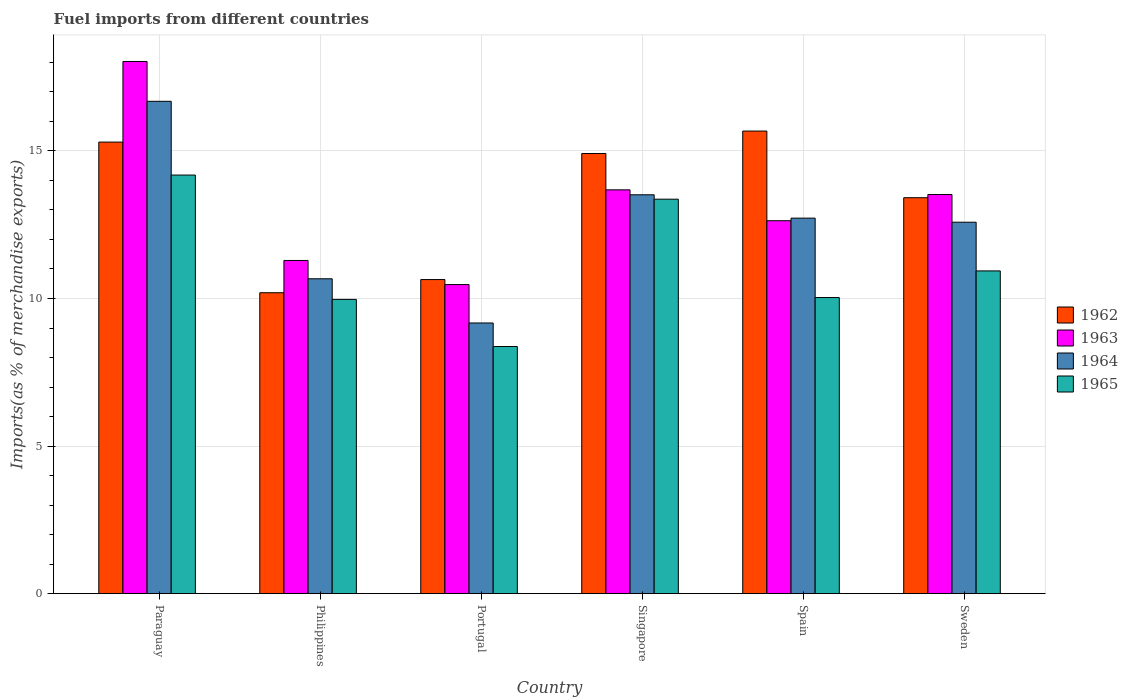Are the number of bars per tick equal to the number of legend labels?
Keep it short and to the point. Yes. Are the number of bars on each tick of the X-axis equal?
Your answer should be compact. Yes. What is the label of the 4th group of bars from the left?
Provide a succinct answer. Singapore. In how many cases, is the number of bars for a given country not equal to the number of legend labels?
Give a very brief answer. 0. What is the percentage of imports to different countries in 1965 in Sweden?
Offer a very short reply. 10.93. Across all countries, what is the maximum percentage of imports to different countries in 1965?
Your response must be concise. 14.18. Across all countries, what is the minimum percentage of imports to different countries in 1964?
Your answer should be very brief. 9.17. In which country was the percentage of imports to different countries in 1963 maximum?
Ensure brevity in your answer.  Paraguay. What is the total percentage of imports to different countries in 1964 in the graph?
Give a very brief answer. 75.34. What is the difference between the percentage of imports to different countries in 1962 in Portugal and that in Singapore?
Give a very brief answer. -4.27. What is the difference between the percentage of imports to different countries in 1962 in Sweden and the percentage of imports to different countries in 1964 in Spain?
Provide a short and direct response. 0.69. What is the average percentage of imports to different countries in 1962 per country?
Your answer should be compact. 13.36. What is the difference between the percentage of imports to different countries of/in 1964 and percentage of imports to different countries of/in 1962 in Philippines?
Keep it short and to the point. 0.47. What is the ratio of the percentage of imports to different countries in 1964 in Philippines to that in Singapore?
Make the answer very short. 0.79. Is the percentage of imports to different countries in 1965 in Portugal less than that in Singapore?
Provide a succinct answer. Yes. Is the difference between the percentage of imports to different countries in 1964 in Philippines and Portugal greater than the difference between the percentage of imports to different countries in 1962 in Philippines and Portugal?
Provide a short and direct response. Yes. What is the difference between the highest and the second highest percentage of imports to different countries in 1962?
Ensure brevity in your answer.  0.39. What is the difference between the highest and the lowest percentage of imports to different countries in 1965?
Keep it short and to the point. 5.81. In how many countries, is the percentage of imports to different countries in 1964 greater than the average percentage of imports to different countries in 1964 taken over all countries?
Keep it short and to the point. 4. Is it the case that in every country, the sum of the percentage of imports to different countries in 1964 and percentage of imports to different countries in 1965 is greater than the sum of percentage of imports to different countries in 1962 and percentage of imports to different countries in 1963?
Give a very brief answer. No. What does the 1st bar from the left in Paraguay represents?
Keep it short and to the point. 1962. How many bars are there?
Provide a succinct answer. 24. How many countries are there in the graph?
Give a very brief answer. 6. Where does the legend appear in the graph?
Provide a succinct answer. Center right. What is the title of the graph?
Provide a short and direct response. Fuel imports from different countries. What is the label or title of the X-axis?
Ensure brevity in your answer.  Country. What is the label or title of the Y-axis?
Your response must be concise. Imports(as % of merchandise exports). What is the Imports(as % of merchandise exports) in 1962 in Paraguay?
Keep it short and to the point. 15.3. What is the Imports(as % of merchandise exports) of 1963 in Paraguay?
Make the answer very short. 18.03. What is the Imports(as % of merchandise exports) in 1964 in Paraguay?
Give a very brief answer. 16.68. What is the Imports(as % of merchandise exports) of 1965 in Paraguay?
Your answer should be compact. 14.18. What is the Imports(as % of merchandise exports) of 1962 in Philippines?
Your response must be concise. 10.2. What is the Imports(as % of merchandise exports) in 1963 in Philippines?
Your response must be concise. 11.29. What is the Imports(as % of merchandise exports) of 1964 in Philippines?
Your answer should be very brief. 10.67. What is the Imports(as % of merchandise exports) in 1965 in Philippines?
Your answer should be compact. 9.97. What is the Imports(as % of merchandise exports) in 1962 in Portugal?
Make the answer very short. 10.64. What is the Imports(as % of merchandise exports) in 1963 in Portugal?
Provide a succinct answer. 10.47. What is the Imports(as % of merchandise exports) of 1964 in Portugal?
Give a very brief answer. 9.17. What is the Imports(as % of merchandise exports) of 1965 in Portugal?
Offer a very short reply. 8.37. What is the Imports(as % of merchandise exports) in 1962 in Singapore?
Your answer should be very brief. 14.91. What is the Imports(as % of merchandise exports) of 1963 in Singapore?
Offer a very short reply. 13.68. What is the Imports(as % of merchandise exports) of 1964 in Singapore?
Provide a short and direct response. 13.51. What is the Imports(as % of merchandise exports) of 1965 in Singapore?
Make the answer very short. 13.37. What is the Imports(as % of merchandise exports) of 1962 in Spain?
Give a very brief answer. 15.67. What is the Imports(as % of merchandise exports) of 1963 in Spain?
Make the answer very short. 12.64. What is the Imports(as % of merchandise exports) in 1964 in Spain?
Make the answer very short. 12.72. What is the Imports(as % of merchandise exports) of 1965 in Spain?
Provide a short and direct response. 10.03. What is the Imports(as % of merchandise exports) in 1962 in Sweden?
Your response must be concise. 13.42. What is the Imports(as % of merchandise exports) in 1963 in Sweden?
Ensure brevity in your answer.  13.52. What is the Imports(as % of merchandise exports) of 1964 in Sweden?
Your answer should be very brief. 12.58. What is the Imports(as % of merchandise exports) in 1965 in Sweden?
Keep it short and to the point. 10.93. Across all countries, what is the maximum Imports(as % of merchandise exports) of 1962?
Give a very brief answer. 15.67. Across all countries, what is the maximum Imports(as % of merchandise exports) in 1963?
Your response must be concise. 18.03. Across all countries, what is the maximum Imports(as % of merchandise exports) of 1964?
Make the answer very short. 16.68. Across all countries, what is the maximum Imports(as % of merchandise exports) in 1965?
Offer a terse response. 14.18. Across all countries, what is the minimum Imports(as % of merchandise exports) in 1962?
Provide a succinct answer. 10.2. Across all countries, what is the minimum Imports(as % of merchandise exports) of 1963?
Offer a very short reply. 10.47. Across all countries, what is the minimum Imports(as % of merchandise exports) of 1964?
Your response must be concise. 9.17. Across all countries, what is the minimum Imports(as % of merchandise exports) of 1965?
Keep it short and to the point. 8.37. What is the total Imports(as % of merchandise exports) in 1962 in the graph?
Offer a terse response. 80.14. What is the total Imports(as % of merchandise exports) of 1963 in the graph?
Your answer should be compact. 79.63. What is the total Imports(as % of merchandise exports) of 1964 in the graph?
Offer a terse response. 75.34. What is the total Imports(as % of merchandise exports) of 1965 in the graph?
Offer a terse response. 66.86. What is the difference between the Imports(as % of merchandise exports) in 1962 in Paraguay and that in Philippines?
Make the answer very short. 5.1. What is the difference between the Imports(as % of merchandise exports) of 1963 in Paraguay and that in Philippines?
Provide a succinct answer. 6.74. What is the difference between the Imports(as % of merchandise exports) in 1964 in Paraguay and that in Philippines?
Ensure brevity in your answer.  6.01. What is the difference between the Imports(as % of merchandise exports) in 1965 in Paraguay and that in Philippines?
Offer a terse response. 4.21. What is the difference between the Imports(as % of merchandise exports) of 1962 in Paraguay and that in Portugal?
Offer a very short reply. 4.66. What is the difference between the Imports(as % of merchandise exports) of 1963 in Paraguay and that in Portugal?
Your answer should be very brief. 7.56. What is the difference between the Imports(as % of merchandise exports) in 1964 in Paraguay and that in Portugal?
Provide a succinct answer. 7.51. What is the difference between the Imports(as % of merchandise exports) in 1965 in Paraguay and that in Portugal?
Make the answer very short. 5.81. What is the difference between the Imports(as % of merchandise exports) in 1962 in Paraguay and that in Singapore?
Offer a terse response. 0.39. What is the difference between the Imports(as % of merchandise exports) of 1963 in Paraguay and that in Singapore?
Ensure brevity in your answer.  4.35. What is the difference between the Imports(as % of merchandise exports) of 1964 in Paraguay and that in Singapore?
Give a very brief answer. 3.17. What is the difference between the Imports(as % of merchandise exports) in 1965 in Paraguay and that in Singapore?
Make the answer very short. 0.82. What is the difference between the Imports(as % of merchandise exports) of 1962 in Paraguay and that in Spain?
Your answer should be compact. -0.37. What is the difference between the Imports(as % of merchandise exports) of 1963 in Paraguay and that in Spain?
Offer a very short reply. 5.4. What is the difference between the Imports(as % of merchandise exports) in 1964 in Paraguay and that in Spain?
Your response must be concise. 3.96. What is the difference between the Imports(as % of merchandise exports) in 1965 in Paraguay and that in Spain?
Your answer should be very brief. 4.15. What is the difference between the Imports(as % of merchandise exports) of 1962 in Paraguay and that in Sweden?
Provide a succinct answer. 1.88. What is the difference between the Imports(as % of merchandise exports) in 1963 in Paraguay and that in Sweden?
Your response must be concise. 4.51. What is the difference between the Imports(as % of merchandise exports) in 1964 in Paraguay and that in Sweden?
Give a very brief answer. 4.1. What is the difference between the Imports(as % of merchandise exports) in 1965 in Paraguay and that in Sweden?
Offer a very short reply. 3.25. What is the difference between the Imports(as % of merchandise exports) in 1962 in Philippines and that in Portugal?
Offer a terse response. -0.45. What is the difference between the Imports(as % of merchandise exports) in 1963 in Philippines and that in Portugal?
Offer a very short reply. 0.82. What is the difference between the Imports(as % of merchandise exports) in 1964 in Philippines and that in Portugal?
Provide a succinct answer. 1.5. What is the difference between the Imports(as % of merchandise exports) in 1965 in Philippines and that in Portugal?
Your response must be concise. 1.6. What is the difference between the Imports(as % of merchandise exports) in 1962 in Philippines and that in Singapore?
Ensure brevity in your answer.  -4.72. What is the difference between the Imports(as % of merchandise exports) of 1963 in Philippines and that in Singapore?
Make the answer very short. -2.39. What is the difference between the Imports(as % of merchandise exports) in 1964 in Philippines and that in Singapore?
Offer a terse response. -2.85. What is the difference between the Imports(as % of merchandise exports) of 1965 in Philippines and that in Singapore?
Offer a very short reply. -3.4. What is the difference between the Imports(as % of merchandise exports) of 1962 in Philippines and that in Spain?
Keep it short and to the point. -5.48. What is the difference between the Imports(as % of merchandise exports) of 1963 in Philippines and that in Spain?
Your response must be concise. -1.35. What is the difference between the Imports(as % of merchandise exports) of 1964 in Philippines and that in Spain?
Provide a short and direct response. -2.05. What is the difference between the Imports(as % of merchandise exports) of 1965 in Philippines and that in Spain?
Your answer should be compact. -0.06. What is the difference between the Imports(as % of merchandise exports) of 1962 in Philippines and that in Sweden?
Provide a succinct answer. -3.22. What is the difference between the Imports(as % of merchandise exports) of 1963 in Philippines and that in Sweden?
Your answer should be compact. -2.23. What is the difference between the Imports(as % of merchandise exports) of 1964 in Philippines and that in Sweden?
Your response must be concise. -1.92. What is the difference between the Imports(as % of merchandise exports) in 1965 in Philippines and that in Sweden?
Ensure brevity in your answer.  -0.96. What is the difference between the Imports(as % of merchandise exports) in 1962 in Portugal and that in Singapore?
Your response must be concise. -4.27. What is the difference between the Imports(as % of merchandise exports) of 1963 in Portugal and that in Singapore?
Provide a succinct answer. -3.21. What is the difference between the Imports(as % of merchandise exports) of 1964 in Portugal and that in Singapore?
Make the answer very short. -4.34. What is the difference between the Imports(as % of merchandise exports) in 1965 in Portugal and that in Singapore?
Your response must be concise. -4.99. What is the difference between the Imports(as % of merchandise exports) of 1962 in Portugal and that in Spain?
Offer a terse response. -5.03. What is the difference between the Imports(as % of merchandise exports) in 1963 in Portugal and that in Spain?
Your response must be concise. -2.16. What is the difference between the Imports(as % of merchandise exports) in 1964 in Portugal and that in Spain?
Your response must be concise. -3.55. What is the difference between the Imports(as % of merchandise exports) in 1965 in Portugal and that in Spain?
Give a very brief answer. -1.66. What is the difference between the Imports(as % of merchandise exports) of 1962 in Portugal and that in Sweden?
Give a very brief answer. -2.77. What is the difference between the Imports(as % of merchandise exports) of 1963 in Portugal and that in Sweden?
Provide a succinct answer. -3.05. What is the difference between the Imports(as % of merchandise exports) in 1964 in Portugal and that in Sweden?
Offer a terse response. -3.41. What is the difference between the Imports(as % of merchandise exports) of 1965 in Portugal and that in Sweden?
Your answer should be very brief. -2.56. What is the difference between the Imports(as % of merchandise exports) of 1962 in Singapore and that in Spain?
Ensure brevity in your answer.  -0.76. What is the difference between the Imports(as % of merchandise exports) in 1963 in Singapore and that in Spain?
Ensure brevity in your answer.  1.05. What is the difference between the Imports(as % of merchandise exports) in 1964 in Singapore and that in Spain?
Provide a short and direct response. 0.79. What is the difference between the Imports(as % of merchandise exports) in 1965 in Singapore and that in Spain?
Make the answer very short. 3.33. What is the difference between the Imports(as % of merchandise exports) of 1962 in Singapore and that in Sweden?
Ensure brevity in your answer.  1.5. What is the difference between the Imports(as % of merchandise exports) of 1963 in Singapore and that in Sweden?
Your response must be concise. 0.16. What is the difference between the Imports(as % of merchandise exports) of 1964 in Singapore and that in Sweden?
Ensure brevity in your answer.  0.93. What is the difference between the Imports(as % of merchandise exports) of 1965 in Singapore and that in Sweden?
Keep it short and to the point. 2.43. What is the difference between the Imports(as % of merchandise exports) of 1962 in Spain and that in Sweden?
Your answer should be compact. 2.26. What is the difference between the Imports(as % of merchandise exports) in 1963 in Spain and that in Sweden?
Ensure brevity in your answer.  -0.89. What is the difference between the Imports(as % of merchandise exports) in 1964 in Spain and that in Sweden?
Offer a very short reply. 0.14. What is the difference between the Imports(as % of merchandise exports) of 1965 in Spain and that in Sweden?
Provide a short and direct response. -0.9. What is the difference between the Imports(as % of merchandise exports) in 1962 in Paraguay and the Imports(as % of merchandise exports) in 1963 in Philippines?
Keep it short and to the point. 4.01. What is the difference between the Imports(as % of merchandise exports) in 1962 in Paraguay and the Imports(as % of merchandise exports) in 1964 in Philippines?
Your answer should be compact. 4.63. What is the difference between the Imports(as % of merchandise exports) of 1962 in Paraguay and the Imports(as % of merchandise exports) of 1965 in Philippines?
Your answer should be very brief. 5.33. What is the difference between the Imports(as % of merchandise exports) of 1963 in Paraguay and the Imports(as % of merchandise exports) of 1964 in Philippines?
Your answer should be very brief. 7.36. What is the difference between the Imports(as % of merchandise exports) in 1963 in Paraguay and the Imports(as % of merchandise exports) in 1965 in Philippines?
Provide a short and direct response. 8.06. What is the difference between the Imports(as % of merchandise exports) of 1964 in Paraguay and the Imports(as % of merchandise exports) of 1965 in Philippines?
Provide a succinct answer. 6.71. What is the difference between the Imports(as % of merchandise exports) in 1962 in Paraguay and the Imports(as % of merchandise exports) in 1963 in Portugal?
Keep it short and to the point. 4.83. What is the difference between the Imports(as % of merchandise exports) in 1962 in Paraguay and the Imports(as % of merchandise exports) in 1964 in Portugal?
Keep it short and to the point. 6.13. What is the difference between the Imports(as % of merchandise exports) of 1962 in Paraguay and the Imports(as % of merchandise exports) of 1965 in Portugal?
Offer a terse response. 6.93. What is the difference between the Imports(as % of merchandise exports) in 1963 in Paraguay and the Imports(as % of merchandise exports) in 1964 in Portugal?
Make the answer very short. 8.86. What is the difference between the Imports(as % of merchandise exports) in 1963 in Paraguay and the Imports(as % of merchandise exports) in 1965 in Portugal?
Keep it short and to the point. 9.66. What is the difference between the Imports(as % of merchandise exports) in 1964 in Paraguay and the Imports(as % of merchandise exports) in 1965 in Portugal?
Provide a succinct answer. 8.31. What is the difference between the Imports(as % of merchandise exports) in 1962 in Paraguay and the Imports(as % of merchandise exports) in 1963 in Singapore?
Provide a succinct answer. 1.62. What is the difference between the Imports(as % of merchandise exports) of 1962 in Paraguay and the Imports(as % of merchandise exports) of 1964 in Singapore?
Ensure brevity in your answer.  1.79. What is the difference between the Imports(as % of merchandise exports) of 1962 in Paraguay and the Imports(as % of merchandise exports) of 1965 in Singapore?
Offer a terse response. 1.93. What is the difference between the Imports(as % of merchandise exports) of 1963 in Paraguay and the Imports(as % of merchandise exports) of 1964 in Singapore?
Give a very brief answer. 4.52. What is the difference between the Imports(as % of merchandise exports) in 1963 in Paraguay and the Imports(as % of merchandise exports) in 1965 in Singapore?
Keep it short and to the point. 4.67. What is the difference between the Imports(as % of merchandise exports) of 1964 in Paraguay and the Imports(as % of merchandise exports) of 1965 in Singapore?
Provide a short and direct response. 3.32. What is the difference between the Imports(as % of merchandise exports) of 1962 in Paraguay and the Imports(as % of merchandise exports) of 1963 in Spain?
Your answer should be compact. 2.66. What is the difference between the Imports(as % of merchandise exports) of 1962 in Paraguay and the Imports(as % of merchandise exports) of 1964 in Spain?
Your answer should be compact. 2.58. What is the difference between the Imports(as % of merchandise exports) in 1962 in Paraguay and the Imports(as % of merchandise exports) in 1965 in Spain?
Provide a short and direct response. 5.27. What is the difference between the Imports(as % of merchandise exports) in 1963 in Paraguay and the Imports(as % of merchandise exports) in 1964 in Spain?
Ensure brevity in your answer.  5.31. What is the difference between the Imports(as % of merchandise exports) of 1963 in Paraguay and the Imports(as % of merchandise exports) of 1965 in Spain?
Your answer should be compact. 8. What is the difference between the Imports(as % of merchandise exports) in 1964 in Paraguay and the Imports(as % of merchandise exports) in 1965 in Spain?
Provide a succinct answer. 6.65. What is the difference between the Imports(as % of merchandise exports) in 1962 in Paraguay and the Imports(as % of merchandise exports) in 1963 in Sweden?
Provide a succinct answer. 1.78. What is the difference between the Imports(as % of merchandise exports) of 1962 in Paraguay and the Imports(as % of merchandise exports) of 1964 in Sweden?
Your answer should be compact. 2.71. What is the difference between the Imports(as % of merchandise exports) of 1962 in Paraguay and the Imports(as % of merchandise exports) of 1965 in Sweden?
Provide a succinct answer. 4.36. What is the difference between the Imports(as % of merchandise exports) of 1963 in Paraguay and the Imports(as % of merchandise exports) of 1964 in Sweden?
Your answer should be very brief. 5.45. What is the difference between the Imports(as % of merchandise exports) in 1963 in Paraguay and the Imports(as % of merchandise exports) in 1965 in Sweden?
Offer a terse response. 7.1. What is the difference between the Imports(as % of merchandise exports) of 1964 in Paraguay and the Imports(as % of merchandise exports) of 1965 in Sweden?
Your answer should be compact. 5.75. What is the difference between the Imports(as % of merchandise exports) of 1962 in Philippines and the Imports(as % of merchandise exports) of 1963 in Portugal?
Keep it short and to the point. -0.28. What is the difference between the Imports(as % of merchandise exports) of 1962 in Philippines and the Imports(as % of merchandise exports) of 1964 in Portugal?
Offer a terse response. 1.03. What is the difference between the Imports(as % of merchandise exports) in 1962 in Philippines and the Imports(as % of merchandise exports) in 1965 in Portugal?
Ensure brevity in your answer.  1.82. What is the difference between the Imports(as % of merchandise exports) in 1963 in Philippines and the Imports(as % of merchandise exports) in 1964 in Portugal?
Your response must be concise. 2.12. What is the difference between the Imports(as % of merchandise exports) in 1963 in Philippines and the Imports(as % of merchandise exports) in 1965 in Portugal?
Provide a short and direct response. 2.92. What is the difference between the Imports(as % of merchandise exports) in 1964 in Philippines and the Imports(as % of merchandise exports) in 1965 in Portugal?
Provide a succinct answer. 2.3. What is the difference between the Imports(as % of merchandise exports) in 1962 in Philippines and the Imports(as % of merchandise exports) in 1963 in Singapore?
Provide a succinct answer. -3.49. What is the difference between the Imports(as % of merchandise exports) of 1962 in Philippines and the Imports(as % of merchandise exports) of 1964 in Singapore?
Make the answer very short. -3.32. What is the difference between the Imports(as % of merchandise exports) in 1962 in Philippines and the Imports(as % of merchandise exports) in 1965 in Singapore?
Keep it short and to the point. -3.17. What is the difference between the Imports(as % of merchandise exports) in 1963 in Philippines and the Imports(as % of merchandise exports) in 1964 in Singapore?
Offer a terse response. -2.23. What is the difference between the Imports(as % of merchandise exports) of 1963 in Philippines and the Imports(as % of merchandise exports) of 1965 in Singapore?
Keep it short and to the point. -2.08. What is the difference between the Imports(as % of merchandise exports) in 1964 in Philippines and the Imports(as % of merchandise exports) in 1965 in Singapore?
Provide a short and direct response. -2.7. What is the difference between the Imports(as % of merchandise exports) in 1962 in Philippines and the Imports(as % of merchandise exports) in 1963 in Spain?
Your response must be concise. -2.44. What is the difference between the Imports(as % of merchandise exports) of 1962 in Philippines and the Imports(as % of merchandise exports) of 1964 in Spain?
Your answer should be very brief. -2.53. What is the difference between the Imports(as % of merchandise exports) in 1962 in Philippines and the Imports(as % of merchandise exports) in 1965 in Spain?
Ensure brevity in your answer.  0.16. What is the difference between the Imports(as % of merchandise exports) of 1963 in Philippines and the Imports(as % of merchandise exports) of 1964 in Spain?
Ensure brevity in your answer.  -1.43. What is the difference between the Imports(as % of merchandise exports) of 1963 in Philippines and the Imports(as % of merchandise exports) of 1965 in Spain?
Give a very brief answer. 1.26. What is the difference between the Imports(as % of merchandise exports) in 1964 in Philippines and the Imports(as % of merchandise exports) in 1965 in Spain?
Offer a very short reply. 0.64. What is the difference between the Imports(as % of merchandise exports) of 1962 in Philippines and the Imports(as % of merchandise exports) of 1963 in Sweden?
Offer a terse response. -3.33. What is the difference between the Imports(as % of merchandise exports) of 1962 in Philippines and the Imports(as % of merchandise exports) of 1964 in Sweden?
Ensure brevity in your answer.  -2.39. What is the difference between the Imports(as % of merchandise exports) in 1962 in Philippines and the Imports(as % of merchandise exports) in 1965 in Sweden?
Your answer should be compact. -0.74. What is the difference between the Imports(as % of merchandise exports) in 1963 in Philippines and the Imports(as % of merchandise exports) in 1964 in Sweden?
Keep it short and to the point. -1.3. What is the difference between the Imports(as % of merchandise exports) in 1963 in Philippines and the Imports(as % of merchandise exports) in 1965 in Sweden?
Provide a succinct answer. 0.35. What is the difference between the Imports(as % of merchandise exports) in 1964 in Philippines and the Imports(as % of merchandise exports) in 1965 in Sweden?
Your answer should be very brief. -0.27. What is the difference between the Imports(as % of merchandise exports) in 1962 in Portugal and the Imports(as % of merchandise exports) in 1963 in Singapore?
Your response must be concise. -3.04. What is the difference between the Imports(as % of merchandise exports) in 1962 in Portugal and the Imports(as % of merchandise exports) in 1964 in Singapore?
Give a very brief answer. -2.87. What is the difference between the Imports(as % of merchandise exports) of 1962 in Portugal and the Imports(as % of merchandise exports) of 1965 in Singapore?
Make the answer very short. -2.72. What is the difference between the Imports(as % of merchandise exports) of 1963 in Portugal and the Imports(as % of merchandise exports) of 1964 in Singapore?
Provide a succinct answer. -3.04. What is the difference between the Imports(as % of merchandise exports) of 1963 in Portugal and the Imports(as % of merchandise exports) of 1965 in Singapore?
Keep it short and to the point. -2.89. What is the difference between the Imports(as % of merchandise exports) of 1964 in Portugal and the Imports(as % of merchandise exports) of 1965 in Singapore?
Your response must be concise. -4.19. What is the difference between the Imports(as % of merchandise exports) of 1962 in Portugal and the Imports(as % of merchandise exports) of 1963 in Spain?
Your answer should be very brief. -1.99. What is the difference between the Imports(as % of merchandise exports) in 1962 in Portugal and the Imports(as % of merchandise exports) in 1964 in Spain?
Offer a terse response. -2.08. What is the difference between the Imports(as % of merchandise exports) in 1962 in Portugal and the Imports(as % of merchandise exports) in 1965 in Spain?
Give a very brief answer. 0.61. What is the difference between the Imports(as % of merchandise exports) in 1963 in Portugal and the Imports(as % of merchandise exports) in 1964 in Spain?
Your response must be concise. -2.25. What is the difference between the Imports(as % of merchandise exports) of 1963 in Portugal and the Imports(as % of merchandise exports) of 1965 in Spain?
Your response must be concise. 0.44. What is the difference between the Imports(as % of merchandise exports) of 1964 in Portugal and the Imports(as % of merchandise exports) of 1965 in Spain?
Provide a succinct answer. -0.86. What is the difference between the Imports(as % of merchandise exports) in 1962 in Portugal and the Imports(as % of merchandise exports) in 1963 in Sweden?
Your response must be concise. -2.88. What is the difference between the Imports(as % of merchandise exports) in 1962 in Portugal and the Imports(as % of merchandise exports) in 1964 in Sweden?
Provide a succinct answer. -1.94. What is the difference between the Imports(as % of merchandise exports) of 1962 in Portugal and the Imports(as % of merchandise exports) of 1965 in Sweden?
Provide a succinct answer. -0.29. What is the difference between the Imports(as % of merchandise exports) of 1963 in Portugal and the Imports(as % of merchandise exports) of 1964 in Sweden?
Offer a terse response. -2.11. What is the difference between the Imports(as % of merchandise exports) in 1963 in Portugal and the Imports(as % of merchandise exports) in 1965 in Sweden?
Your answer should be very brief. -0.46. What is the difference between the Imports(as % of merchandise exports) in 1964 in Portugal and the Imports(as % of merchandise exports) in 1965 in Sweden?
Keep it short and to the point. -1.76. What is the difference between the Imports(as % of merchandise exports) of 1962 in Singapore and the Imports(as % of merchandise exports) of 1963 in Spain?
Offer a very short reply. 2.28. What is the difference between the Imports(as % of merchandise exports) in 1962 in Singapore and the Imports(as % of merchandise exports) in 1964 in Spain?
Provide a short and direct response. 2.19. What is the difference between the Imports(as % of merchandise exports) in 1962 in Singapore and the Imports(as % of merchandise exports) in 1965 in Spain?
Ensure brevity in your answer.  4.88. What is the difference between the Imports(as % of merchandise exports) of 1963 in Singapore and the Imports(as % of merchandise exports) of 1964 in Spain?
Your response must be concise. 0.96. What is the difference between the Imports(as % of merchandise exports) in 1963 in Singapore and the Imports(as % of merchandise exports) in 1965 in Spain?
Give a very brief answer. 3.65. What is the difference between the Imports(as % of merchandise exports) in 1964 in Singapore and the Imports(as % of merchandise exports) in 1965 in Spain?
Your answer should be compact. 3.48. What is the difference between the Imports(as % of merchandise exports) of 1962 in Singapore and the Imports(as % of merchandise exports) of 1963 in Sweden?
Provide a short and direct response. 1.39. What is the difference between the Imports(as % of merchandise exports) in 1962 in Singapore and the Imports(as % of merchandise exports) in 1964 in Sweden?
Your response must be concise. 2.33. What is the difference between the Imports(as % of merchandise exports) of 1962 in Singapore and the Imports(as % of merchandise exports) of 1965 in Sweden?
Offer a terse response. 3.98. What is the difference between the Imports(as % of merchandise exports) of 1963 in Singapore and the Imports(as % of merchandise exports) of 1964 in Sweden?
Offer a very short reply. 1.1. What is the difference between the Imports(as % of merchandise exports) in 1963 in Singapore and the Imports(as % of merchandise exports) in 1965 in Sweden?
Your response must be concise. 2.75. What is the difference between the Imports(as % of merchandise exports) of 1964 in Singapore and the Imports(as % of merchandise exports) of 1965 in Sweden?
Provide a succinct answer. 2.58. What is the difference between the Imports(as % of merchandise exports) of 1962 in Spain and the Imports(as % of merchandise exports) of 1963 in Sweden?
Offer a terse response. 2.15. What is the difference between the Imports(as % of merchandise exports) of 1962 in Spain and the Imports(as % of merchandise exports) of 1964 in Sweden?
Provide a succinct answer. 3.09. What is the difference between the Imports(as % of merchandise exports) in 1962 in Spain and the Imports(as % of merchandise exports) in 1965 in Sweden?
Your answer should be very brief. 4.74. What is the difference between the Imports(as % of merchandise exports) of 1963 in Spain and the Imports(as % of merchandise exports) of 1964 in Sweden?
Your answer should be compact. 0.05. What is the difference between the Imports(as % of merchandise exports) of 1963 in Spain and the Imports(as % of merchandise exports) of 1965 in Sweden?
Offer a terse response. 1.7. What is the difference between the Imports(as % of merchandise exports) in 1964 in Spain and the Imports(as % of merchandise exports) in 1965 in Sweden?
Keep it short and to the point. 1.79. What is the average Imports(as % of merchandise exports) of 1962 per country?
Keep it short and to the point. 13.36. What is the average Imports(as % of merchandise exports) of 1963 per country?
Offer a terse response. 13.27. What is the average Imports(as % of merchandise exports) in 1964 per country?
Provide a short and direct response. 12.56. What is the average Imports(as % of merchandise exports) of 1965 per country?
Offer a terse response. 11.14. What is the difference between the Imports(as % of merchandise exports) of 1962 and Imports(as % of merchandise exports) of 1963 in Paraguay?
Give a very brief answer. -2.73. What is the difference between the Imports(as % of merchandise exports) of 1962 and Imports(as % of merchandise exports) of 1964 in Paraguay?
Offer a terse response. -1.38. What is the difference between the Imports(as % of merchandise exports) of 1962 and Imports(as % of merchandise exports) of 1965 in Paraguay?
Give a very brief answer. 1.12. What is the difference between the Imports(as % of merchandise exports) in 1963 and Imports(as % of merchandise exports) in 1964 in Paraguay?
Ensure brevity in your answer.  1.35. What is the difference between the Imports(as % of merchandise exports) in 1963 and Imports(as % of merchandise exports) in 1965 in Paraguay?
Ensure brevity in your answer.  3.85. What is the difference between the Imports(as % of merchandise exports) of 1964 and Imports(as % of merchandise exports) of 1965 in Paraguay?
Ensure brevity in your answer.  2.5. What is the difference between the Imports(as % of merchandise exports) in 1962 and Imports(as % of merchandise exports) in 1963 in Philippines?
Provide a short and direct response. -1.09. What is the difference between the Imports(as % of merchandise exports) in 1962 and Imports(as % of merchandise exports) in 1964 in Philippines?
Keep it short and to the point. -0.47. What is the difference between the Imports(as % of merchandise exports) in 1962 and Imports(as % of merchandise exports) in 1965 in Philippines?
Make the answer very short. 0.23. What is the difference between the Imports(as % of merchandise exports) in 1963 and Imports(as % of merchandise exports) in 1964 in Philippines?
Offer a terse response. 0.62. What is the difference between the Imports(as % of merchandise exports) in 1963 and Imports(as % of merchandise exports) in 1965 in Philippines?
Your answer should be compact. 1.32. What is the difference between the Imports(as % of merchandise exports) in 1964 and Imports(as % of merchandise exports) in 1965 in Philippines?
Provide a succinct answer. 0.7. What is the difference between the Imports(as % of merchandise exports) in 1962 and Imports(as % of merchandise exports) in 1963 in Portugal?
Keep it short and to the point. 0.17. What is the difference between the Imports(as % of merchandise exports) of 1962 and Imports(as % of merchandise exports) of 1964 in Portugal?
Provide a succinct answer. 1.47. What is the difference between the Imports(as % of merchandise exports) in 1962 and Imports(as % of merchandise exports) in 1965 in Portugal?
Provide a succinct answer. 2.27. What is the difference between the Imports(as % of merchandise exports) in 1963 and Imports(as % of merchandise exports) in 1964 in Portugal?
Offer a terse response. 1.3. What is the difference between the Imports(as % of merchandise exports) of 1963 and Imports(as % of merchandise exports) of 1965 in Portugal?
Give a very brief answer. 2.1. What is the difference between the Imports(as % of merchandise exports) of 1964 and Imports(as % of merchandise exports) of 1965 in Portugal?
Make the answer very short. 0.8. What is the difference between the Imports(as % of merchandise exports) in 1962 and Imports(as % of merchandise exports) in 1963 in Singapore?
Your response must be concise. 1.23. What is the difference between the Imports(as % of merchandise exports) in 1962 and Imports(as % of merchandise exports) in 1964 in Singapore?
Your response must be concise. 1.4. What is the difference between the Imports(as % of merchandise exports) of 1962 and Imports(as % of merchandise exports) of 1965 in Singapore?
Ensure brevity in your answer.  1.55. What is the difference between the Imports(as % of merchandise exports) in 1963 and Imports(as % of merchandise exports) in 1964 in Singapore?
Your response must be concise. 0.17. What is the difference between the Imports(as % of merchandise exports) in 1963 and Imports(as % of merchandise exports) in 1965 in Singapore?
Give a very brief answer. 0.32. What is the difference between the Imports(as % of merchandise exports) in 1964 and Imports(as % of merchandise exports) in 1965 in Singapore?
Your response must be concise. 0.15. What is the difference between the Imports(as % of merchandise exports) in 1962 and Imports(as % of merchandise exports) in 1963 in Spain?
Make the answer very short. 3.04. What is the difference between the Imports(as % of merchandise exports) of 1962 and Imports(as % of merchandise exports) of 1964 in Spain?
Give a very brief answer. 2.95. What is the difference between the Imports(as % of merchandise exports) in 1962 and Imports(as % of merchandise exports) in 1965 in Spain?
Your answer should be compact. 5.64. What is the difference between the Imports(as % of merchandise exports) of 1963 and Imports(as % of merchandise exports) of 1964 in Spain?
Offer a terse response. -0.09. What is the difference between the Imports(as % of merchandise exports) of 1963 and Imports(as % of merchandise exports) of 1965 in Spain?
Make the answer very short. 2.6. What is the difference between the Imports(as % of merchandise exports) in 1964 and Imports(as % of merchandise exports) in 1965 in Spain?
Make the answer very short. 2.69. What is the difference between the Imports(as % of merchandise exports) of 1962 and Imports(as % of merchandise exports) of 1963 in Sweden?
Provide a short and direct response. -0.11. What is the difference between the Imports(as % of merchandise exports) of 1962 and Imports(as % of merchandise exports) of 1964 in Sweden?
Provide a succinct answer. 0.83. What is the difference between the Imports(as % of merchandise exports) of 1962 and Imports(as % of merchandise exports) of 1965 in Sweden?
Provide a short and direct response. 2.48. What is the difference between the Imports(as % of merchandise exports) in 1963 and Imports(as % of merchandise exports) in 1964 in Sweden?
Offer a very short reply. 0.94. What is the difference between the Imports(as % of merchandise exports) of 1963 and Imports(as % of merchandise exports) of 1965 in Sweden?
Ensure brevity in your answer.  2.59. What is the difference between the Imports(as % of merchandise exports) in 1964 and Imports(as % of merchandise exports) in 1965 in Sweden?
Give a very brief answer. 1.65. What is the ratio of the Imports(as % of merchandise exports) in 1962 in Paraguay to that in Philippines?
Ensure brevity in your answer.  1.5. What is the ratio of the Imports(as % of merchandise exports) of 1963 in Paraguay to that in Philippines?
Make the answer very short. 1.6. What is the ratio of the Imports(as % of merchandise exports) in 1964 in Paraguay to that in Philippines?
Your answer should be compact. 1.56. What is the ratio of the Imports(as % of merchandise exports) of 1965 in Paraguay to that in Philippines?
Your answer should be very brief. 1.42. What is the ratio of the Imports(as % of merchandise exports) in 1962 in Paraguay to that in Portugal?
Offer a very short reply. 1.44. What is the ratio of the Imports(as % of merchandise exports) of 1963 in Paraguay to that in Portugal?
Your answer should be very brief. 1.72. What is the ratio of the Imports(as % of merchandise exports) of 1964 in Paraguay to that in Portugal?
Your answer should be very brief. 1.82. What is the ratio of the Imports(as % of merchandise exports) in 1965 in Paraguay to that in Portugal?
Offer a very short reply. 1.69. What is the ratio of the Imports(as % of merchandise exports) in 1962 in Paraguay to that in Singapore?
Offer a very short reply. 1.03. What is the ratio of the Imports(as % of merchandise exports) in 1963 in Paraguay to that in Singapore?
Offer a very short reply. 1.32. What is the ratio of the Imports(as % of merchandise exports) in 1964 in Paraguay to that in Singapore?
Make the answer very short. 1.23. What is the ratio of the Imports(as % of merchandise exports) of 1965 in Paraguay to that in Singapore?
Provide a short and direct response. 1.06. What is the ratio of the Imports(as % of merchandise exports) of 1962 in Paraguay to that in Spain?
Your answer should be very brief. 0.98. What is the ratio of the Imports(as % of merchandise exports) of 1963 in Paraguay to that in Spain?
Your response must be concise. 1.43. What is the ratio of the Imports(as % of merchandise exports) of 1964 in Paraguay to that in Spain?
Your answer should be very brief. 1.31. What is the ratio of the Imports(as % of merchandise exports) in 1965 in Paraguay to that in Spain?
Offer a very short reply. 1.41. What is the ratio of the Imports(as % of merchandise exports) of 1962 in Paraguay to that in Sweden?
Your answer should be very brief. 1.14. What is the ratio of the Imports(as % of merchandise exports) of 1964 in Paraguay to that in Sweden?
Offer a terse response. 1.33. What is the ratio of the Imports(as % of merchandise exports) of 1965 in Paraguay to that in Sweden?
Offer a very short reply. 1.3. What is the ratio of the Imports(as % of merchandise exports) of 1962 in Philippines to that in Portugal?
Offer a very short reply. 0.96. What is the ratio of the Imports(as % of merchandise exports) in 1963 in Philippines to that in Portugal?
Your answer should be compact. 1.08. What is the ratio of the Imports(as % of merchandise exports) in 1964 in Philippines to that in Portugal?
Provide a short and direct response. 1.16. What is the ratio of the Imports(as % of merchandise exports) in 1965 in Philippines to that in Portugal?
Keep it short and to the point. 1.19. What is the ratio of the Imports(as % of merchandise exports) in 1962 in Philippines to that in Singapore?
Provide a succinct answer. 0.68. What is the ratio of the Imports(as % of merchandise exports) of 1963 in Philippines to that in Singapore?
Offer a terse response. 0.83. What is the ratio of the Imports(as % of merchandise exports) of 1964 in Philippines to that in Singapore?
Offer a terse response. 0.79. What is the ratio of the Imports(as % of merchandise exports) of 1965 in Philippines to that in Singapore?
Make the answer very short. 0.75. What is the ratio of the Imports(as % of merchandise exports) of 1962 in Philippines to that in Spain?
Offer a terse response. 0.65. What is the ratio of the Imports(as % of merchandise exports) in 1963 in Philippines to that in Spain?
Ensure brevity in your answer.  0.89. What is the ratio of the Imports(as % of merchandise exports) of 1964 in Philippines to that in Spain?
Offer a terse response. 0.84. What is the ratio of the Imports(as % of merchandise exports) of 1965 in Philippines to that in Spain?
Provide a succinct answer. 0.99. What is the ratio of the Imports(as % of merchandise exports) of 1962 in Philippines to that in Sweden?
Offer a terse response. 0.76. What is the ratio of the Imports(as % of merchandise exports) in 1963 in Philippines to that in Sweden?
Your response must be concise. 0.83. What is the ratio of the Imports(as % of merchandise exports) of 1964 in Philippines to that in Sweden?
Provide a succinct answer. 0.85. What is the ratio of the Imports(as % of merchandise exports) in 1965 in Philippines to that in Sweden?
Provide a short and direct response. 0.91. What is the ratio of the Imports(as % of merchandise exports) of 1962 in Portugal to that in Singapore?
Ensure brevity in your answer.  0.71. What is the ratio of the Imports(as % of merchandise exports) in 1963 in Portugal to that in Singapore?
Provide a short and direct response. 0.77. What is the ratio of the Imports(as % of merchandise exports) in 1964 in Portugal to that in Singapore?
Your answer should be very brief. 0.68. What is the ratio of the Imports(as % of merchandise exports) in 1965 in Portugal to that in Singapore?
Keep it short and to the point. 0.63. What is the ratio of the Imports(as % of merchandise exports) of 1962 in Portugal to that in Spain?
Offer a very short reply. 0.68. What is the ratio of the Imports(as % of merchandise exports) of 1963 in Portugal to that in Spain?
Make the answer very short. 0.83. What is the ratio of the Imports(as % of merchandise exports) in 1964 in Portugal to that in Spain?
Provide a succinct answer. 0.72. What is the ratio of the Imports(as % of merchandise exports) of 1965 in Portugal to that in Spain?
Offer a very short reply. 0.83. What is the ratio of the Imports(as % of merchandise exports) in 1962 in Portugal to that in Sweden?
Your answer should be very brief. 0.79. What is the ratio of the Imports(as % of merchandise exports) in 1963 in Portugal to that in Sweden?
Offer a terse response. 0.77. What is the ratio of the Imports(as % of merchandise exports) of 1964 in Portugal to that in Sweden?
Offer a terse response. 0.73. What is the ratio of the Imports(as % of merchandise exports) in 1965 in Portugal to that in Sweden?
Your answer should be compact. 0.77. What is the ratio of the Imports(as % of merchandise exports) in 1962 in Singapore to that in Spain?
Offer a terse response. 0.95. What is the ratio of the Imports(as % of merchandise exports) in 1963 in Singapore to that in Spain?
Offer a terse response. 1.08. What is the ratio of the Imports(as % of merchandise exports) of 1964 in Singapore to that in Spain?
Offer a very short reply. 1.06. What is the ratio of the Imports(as % of merchandise exports) in 1965 in Singapore to that in Spain?
Offer a very short reply. 1.33. What is the ratio of the Imports(as % of merchandise exports) of 1962 in Singapore to that in Sweden?
Give a very brief answer. 1.11. What is the ratio of the Imports(as % of merchandise exports) of 1963 in Singapore to that in Sweden?
Your answer should be compact. 1.01. What is the ratio of the Imports(as % of merchandise exports) in 1964 in Singapore to that in Sweden?
Give a very brief answer. 1.07. What is the ratio of the Imports(as % of merchandise exports) in 1965 in Singapore to that in Sweden?
Make the answer very short. 1.22. What is the ratio of the Imports(as % of merchandise exports) of 1962 in Spain to that in Sweden?
Provide a short and direct response. 1.17. What is the ratio of the Imports(as % of merchandise exports) of 1963 in Spain to that in Sweden?
Your answer should be very brief. 0.93. What is the ratio of the Imports(as % of merchandise exports) in 1964 in Spain to that in Sweden?
Make the answer very short. 1.01. What is the ratio of the Imports(as % of merchandise exports) of 1965 in Spain to that in Sweden?
Your answer should be very brief. 0.92. What is the difference between the highest and the second highest Imports(as % of merchandise exports) of 1962?
Your answer should be very brief. 0.37. What is the difference between the highest and the second highest Imports(as % of merchandise exports) in 1963?
Give a very brief answer. 4.35. What is the difference between the highest and the second highest Imports(as % of merchandise exports) in 1964?
Give a very brief answer. 3.17. What is the difference between the highest and the second highest Imports(as % of merchandise exports) of 1965?
Provide a succinct answer. 0.82. What is the difference between the highest and the lowest Imports(as % of merchandise exports) in 1962?
Keep it short and to the point. 5.48. What is the difference between the highest and the lowest Imports(as % of merchandise exports) of 1963?
Give a very brief answer. 7.56. What is the difference between the highest and the lowest Imports(as % of merchandise exports) in 1964?
Your answer should be very brief. 7.51. What is the difference between the highest and the lowest Imports(as % of merchandise exports) in 1965?
Keep it short and to the point. 5.81. 